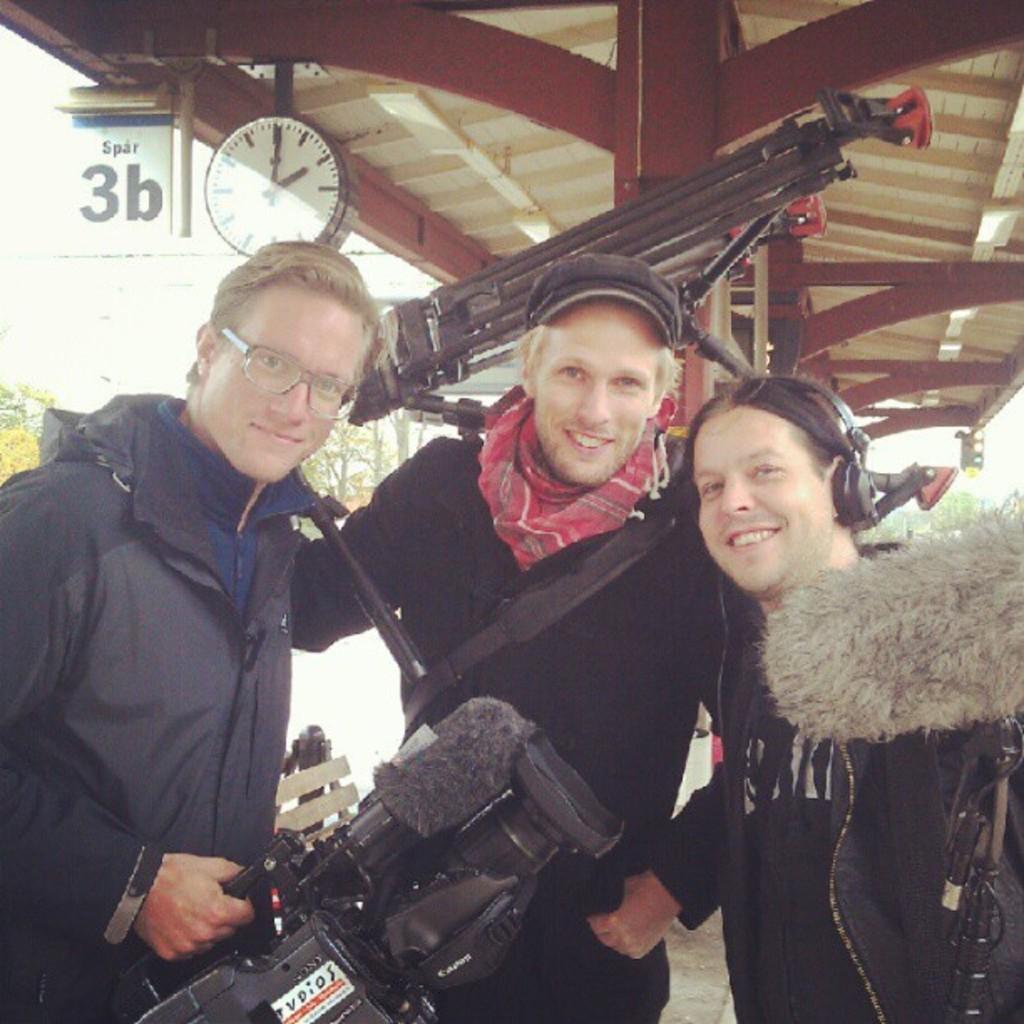Can you describe this image briefly? In the image we can see there are people standing and wearing clothes. This person is wearing spectacles and holding a video camera in his hand. This is a cap, headsets, clock, tree and a footpath. 